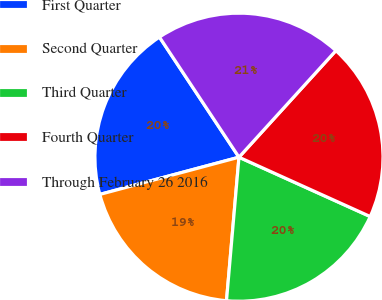<chart> <loc_0><loc_0><loc_500><loc_500><pie_chart><fcel>First Quarter<fcel>Second Quarter<fcel>Third Quarter<fcel>Fourth Quarter<fcel>Through February 26 2016<nl><fcel>19.85%<fcel>19.46%<fcel>19.62%<fcel>20.01%<fcel>21.05%<nl></chart> 